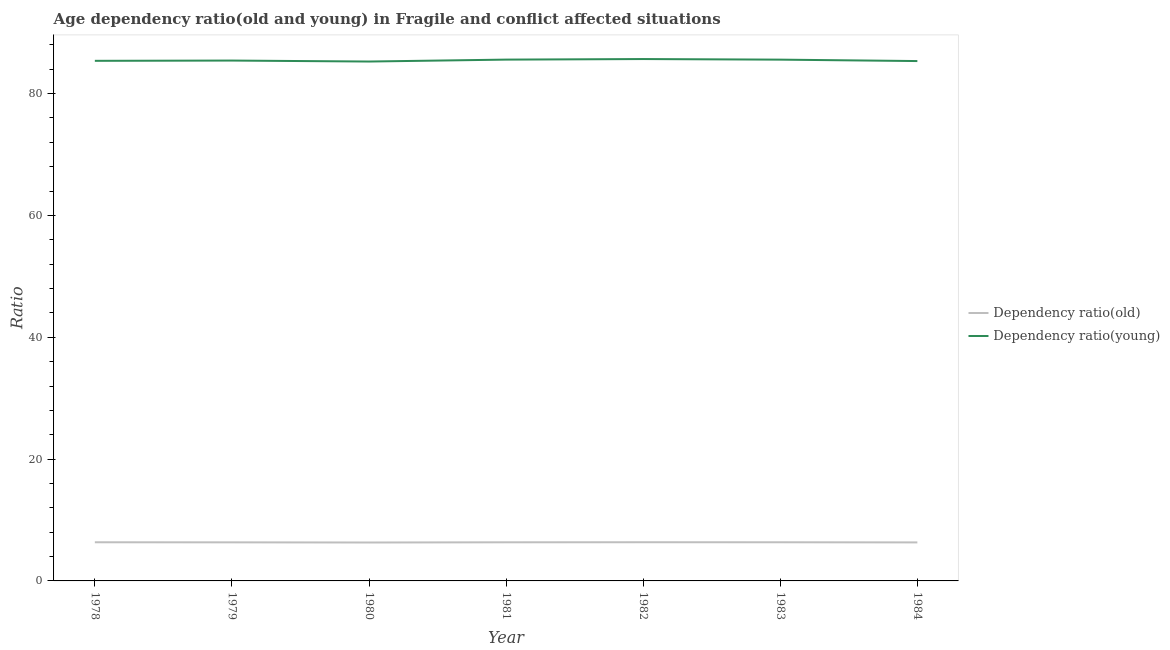Does the line corresponding to age dependency ratio(old) intersect with the line corresponding to age dependency ratio(young)?
Give a very brief answer. No. Is the number of lines equal to the number of legend labels?
Your answer should be compact. Yes. What is the age dependency ratio(young) in 1979?
Provide a succinct answer. 85.43. Across all years, what is the maximum age dependency ratio(old)?
Keep it short and to the point. 6.35. Across all years, what is the minimum age dependency ratio(young)?
Your answer should be compact. 85.27. In which year was the age dependency ratio(old) maximum?
Your answer should be compact. 1982. In which year was the age dependency ratio(old) minimum?
Provide a succinct answer. 1980. What is the total age dependency ratio(old) in the graph?
Offer a terse response. 44.35. What is the difference between the age dependency ratio(young) in 1979 and that in 1983?
Offer a terse response. -0.15. What is the difference between the age dependency ratio(young) in 1979 and the age dependency ratio(old) in 1984?
Your answer should be compact. 79.1. What is the average age dependency ratio(old) per year?
Your answer should be compact. 6.34. In the year 1980, what is the difference between the age dependency ratio(young) and age dependency ratio(old)?
Ensure brevity in your answer.  78.96. In how many years, is the age dependency ratio(young) greater than 68?
Keep it short and to the point. 7. What is the ratio of the age dependency ratio(old) in 1982 to that in 1983?
Provide a succinct answer. 1. Is the age dependency ratio(young) in 1979 less than that in 1981?
Make the answer very short. Yes. Is the difference between the age dependency ratio(young) in 1982 and 1984 greater than the difference between the age dependency ratio(old) in 1982 and 1984?
Give a very brief answer. Yes. What is the difference between the highest and the second highest age dependency ratio(young)?
Ensure brevity in your answer.  0.09. What is the difference between the highest and the lowest age dependency ratio(young)?
Ensure brevity in your answer.  0.41. In how many years, is the age dependency ratio(old) greater than the average age dependency ratio(old) taken over all years?
Your response must be concise. 4. How many years are there in the graph?
Keep it short and to the point. 7. What is the difference between two consecutive major ticks on the Y-axis?
Offer a very short reply. 20. Are the values on the major ticks of Y-axis written in scientific E-notation?
Provide a short and direct response. No. What is the title of the graph?
Your response must be concise. Age dependency ratio(old and young) in Fragile and conflict affected situations. What is the label or title of the X-axis?
Make the answer very short. Year. What is the label or title of the Y-axis?
Make the answer very short. Ratio. What is the Ratio of Dependency ratio(old) in 1978?
Give a very brief answer. 6.35. What is the Ratio of Dependency ratio(young) in 1978?
Your response must be concise. 85.39. What is the Ratio in Dependency ratio(old) in 1979?
Provide a succinct answer. 6.33. What is the Ratio in Dependency ratio(young) in 1979?
Ensure brevity in your answer.  85.43. What is the Ratio of Dependency ratio(old) in 1980?
Ensure brevity in your answer.  6.31. What is the Ratio in Dependency ratio(young) in 1980?
Your answer should be very brief. 85.27. What is the Ratio in Dependency ratio(old) in 1981?
Provide a short and direct response. 6.34. What is the Ratio of Dependency ratio(young) in 1981?
Your response must be concise. 85.58. What is the Ratio in Dependency ratio(old) in 1982?
Offer a terse response. 6.35. What is the Ratio in Dependency ratio(young) in 1982?
Your answer should be very brief. 85.68. What is the Ratio in Dependency ratio(old) in 1983?
Offer a terse response. 6.35. What is the Ratio in Dependency ratio(young) in 1983?
Your answer should be compact. 85.58. What is the Ratio of Dependency ratio(old) in 1984?
Your answer should be compact. 6.32. What is the Ratio of Dependency ratio(young) in 1984?
Provide a succinct answer. 85.35. Across all years, what is the maximum Ratio of Dependency ratio(old)?
Your answer should be compact. 6.35. Across all years, what is the maximum Ratio of Dependency ratio(young)?
Offer a terse response. 85.68. Across all years, what is the minimum Ratio in Dependency ratio(old)?
Keep it short and to the point. 6.31. Across all years, what is the minimum Ratio of Dependency ratio(young)?
Your response must be concise. 85.27. What is the total Ratio in Dependency ratio(old) in the graph?
Make the answer very short. 44.35. What is the total Ratio in Dependency ratio(young) in the graph?
Keep it short and to the point. 598.27. What is the difference between the Ratio of Dependency ratio(old) in 1978 and that in 1979?
Provide a short and direct response. 0.01. What is the difference between the Ratio of Dependency ratio(young) in 1978 and that in 1979?
Provide a short and direct response. -0.04. What is the difference between the Ratio in Dependency ratio(old) in 1978 and that in 1980?
Provide a short and direct response. 0.04. What is the difference between the Ratio of Dependency ratio(young) in 1978 and that in 1980?
Your answer should be very brief. 0.12. What is the difference between the Ratio in Dependency ratio(old) in 1978 and that in 1981?
Your response must be concise. 0.01. What is the difference between the Ratio of Dependency ratio(young) in 1978 and that in 1981?
Offer a terse response. -0.2. What is the difference between the Ratio of Dependency ratio(old) in 1978 and that in 1982?
Your response must be concise. -0.01. What is the difference between the Ratio in Dependency ratio(young) in 1978 and that in 1982?
Give a very brief answer. -0.29. What is the difference between the Ratio of Dependency ratio(young) in 1978 and that in 1983?
Offer a terse response. -0.19. What is the difference between the Ratio of Dependency ratio(old) in 1978 and that in 1984?
Offer a terse response. 0.02. What is the difference between the Ratio in Dependency ratio(young) in 1978 and that in 1984?
Your answer should be very brief. 0.04. What is the difference between the Ratio of Dependency ratio(old) in 1979 and that in 1980?
Your answer should be compact. 0.03. What is the difference between the Ratio of Dependency ratio(young) in 1979 and that in 1980?
Ensure brevity in your answer.  0.16. What is the difference between the Ratio of Dependency ratio(old) in 1979 and that in 1981?
Offer a terse response. -0.01. What is the difference between the Ratio in Dependency ratio(young) in 1979 and that in 1981?
Offer a terse response. -0.16. What is the difference between the Ratio in Dependency ratio(old) in 1979 and that in 1982?
Give a very brief answer. -0.02. What is the difference between the Ratio in Dependency ratio(young) in 1979 and that in 1982?
Ensure brevity in your answer.  -0.25. What is the difference between the Ratio of Dependency ratio(old) in 1979 and that in 1983?
Your response must be concise. -0.01. What is the difference between the Ratio in Dependency ratio(young) in 1979 and that in 1983?
Offer a very short reply. -0.15. What is the difference between the Ratio in Dependency ratio(old) in 1979 and that in 1984?
Keep it short and to the point. 0.01. What is the difference between the Ratio of Dependency ratio(young) in 1979 and that in 1984?
Ensure brevity in your answer.  0.08. What is the difference between the Ratio in Dependency ratio(old) in 1980 and that in 1981?
Ensure brevity in your answer.  -0.03. What is the difference between the Ratio in Dependency ratio(young) in 1980 and that in 1981?
Ensure brevity in your answer.  -0.32. What is the difference between the Ratio of Dependency ratio(old) in 1980 and that in 1982?
Offer a very short reply. -0.04. What is the difference between the Ratio of Dependency ratio(young) in 1980 and that in 1982?
Your response must be concise. -0.41. What is the difference between the Ratio of Dependency ratio(old) in 1980 and that in 1983?
Keep it short and to the point. -0.04. What is the difference between the Ratio of Dependency ratio(young) in 1980 and that in 1983?
Your answer should be compact. -0.31. What is the difference between the Ratio in Dependency ratio(old) in 1980 and that in 1984?
Ensure brevity in your answer.  -0.02. What is the difference between the Ratio in Dependency ratio(young) in 1980 and that in 1984?
Provide a succinct answer. -0.08. What is the difference between the Ratio in Dependency ratio(old) in 1981 and that in 1982?
Provide a short and direct response. -0.01. What is the difference between the Ratio of Dependency ratio(young) in 1981 and that in 1982?
Provide a succinct answer. -0.09. What is the difference between the Ratio in Dependency ratio(old) in 1981 and that in 1983?
Keep it short and to the point. -0.01. What is the difference between the Ratio in Dependency ratio(young) in 1981 and that in 1983?
Ensure brevity in your answer.  0.01. What is the difference between the Ratio in Dependency ratio(old) in 1981 and that in 1984?
Offer a terse response. 0.02. What is the difference between the Ratio of Dependency ratio(young) in 1981 and that in 1984?
Offer a very short reply. 0.24. What is the difference between the Ratio of Dependency ratio(old) in 1982 and that in 1983?
Make the answer very short. 0.01. What is the difference between the Ratio of Dependency ratio(young) in 1982 and that in 1983?
Keep it short and to the point. 0.1. What is the difference between the Ratio of Dependency ratio(old) in 1982 and that in 1984?
Provide a succinct answer. 0.03. What is the difference between the Ratio in Dependency ratio(young) in 1982 and that in 1984?
Ensure brevity in your answer.  0.33. What is the difference between the Ratio of Dependency ratio(old) in 1983 and that in 1984?
Your response must be concise. 0.02. What is the difference between the Ratio of Dependency ratio(young) in 1983 and that in 1984?
Give a very brief answer. 0.23. What is the difference between the Ratio of Dependency ratio(old) in 1978 and the Ratio of Dependency ratio(young) in 1979?
Provide a succinct answer. -79.08. What is the difference between the Ratio in Dependency ratio(old) in 1978 and the Ratio in Dependency ratio(young) in 1980?
Give a very brief answer. -78.92. What is the difference between the Ratio in Dependency ratio(old) in 1978 and the Ratio in Dependency ratio(young) in 1981?
Provide a short and direct response. -79.24. What is the difference between the Ratio of Dependency ratio(old) in 1978 and the Ratio of Dependency ratio(young) in 1982?
Your answer should be very brief. -79.33. What is the difference between the Ratio of Dependency ratio(old) in 1978 and the Ratio of Dependency ratio(young) in 1983?
Your answer should be compact. -79.23. What is the difference between the Ratio of Dependency ratio(old) in 1978 and the Ratio of Dependency ratio(young) in 1984?
Your response must be concise. -79. What is the difference between the Ratio in Dependency ratio(old) in 1979 and the Ratio in Dependency ratio(young) in 1980?
Make the answer very short. -78.94. What is the difference between the Ratio of Dependency ratio(old) in 1979 and the Ratio of Dependency ratio(young) in 1981?
Offer a terse response. -79.25. What is the difference between the Ratio of Dependency ratio(old) in 1979 and the Ratio of Dependency ratio(young) in 1982?
Ensure brevity in your answer.  -79.34. What is the difference between the Ratio of Dependency ratio(old) in 1979 and the Ratio of Dependency ratio(young) in 1983?
Offer a very short reply. -79.25. What is the difference between the Ratio in Dependency ratio(old) in 1979 and the Ratio in Dependency ratio(young) in 1984?
Keep it short and to the point. -79.01. What is the difference between the Ratio in Dependency ratio(old) in 1980 and the Ratio in Dependency ratio(young) in 1981?
Provide a short and direct response. -79.28. What is the difference between the Ratio in Dependency ratio(old) in 1980 and the Ratio in Dependency ratio(young) in 1982?
Ensure brevity in your answer.  -79.37. What is the difference between the Ratio in Dependency ratio(old) in 1980 and the Ratio in Dependency ratio(young) in 1983?
Your response must be concise. -79.27. What is the difference between the Ratio of Dependency ratio(old) in 1980 and the Ratio of Dependency ratio(young) in 1984?
Provide a succinct answer. -79.04. What is the difference between the Ratio of Dependency ratio(old) in 1981 and the Ratio of Dependency ratio(young) in 1982?
Ensure brevity in your answer.  -79.34. What is the difference between the Ratio in Dependency ratio(old) in 1981 and the Ratio in Dependency ratio(young) in 1983?
Offer a very short reply. -79.24. What is the difference between the Ratio of Dependency ratio(old) in 1981 and the Ratio of Dependency ratio(young) in 1984?
Offer a very short reply. -79.01. What is the difference between the Ratio in Dependency ratio(old) in 1982 and the Ratio in Dependency ratio(young) in 1983?
Provide a succinct answer. -79.23. What is the difference between the Ratio in Dependency ratio(old) in 1982 and the Ratio in Dependency ratio(young) in 1984?
Provide a succinct answer. -78.99. What is the difference between the Ratio in Dependency ratio(old) in 1983 and the Ratio in Dependency ratio(young) in 1984?
Provide a short and direct response. -79. What is the average Ratio in Dependency ratio(old) per year?
Offer a very short reply. 6.34. What is the average Ratio of Dependency ratio(young) per year?
Offer a terse response. 85.47. In the year 1978, what is the difference between the Ratio in Dependency ratio(old) and Ratio in Dependency ratio(young)?
Your response must be concise. -79.04. In the year 1979, what is the difference between the Ratio in Dependency ratio(old) and Ratio in Dependency ratio(young)?
Make the answer very short. -79.09. In the year 1980, what is the difference between the Ratio in Dependency ratio(old) and Ratio in Dependency ratio(young)?
Your answer should be very brief. -78.96. In the year 1981, what is the difference between the Ratio of Dependency ratio(old) and Ratio of Dependency ratio(young)?
Provide a short and direct response. -79.24. In the year 1982, what is the difference between the Ratio of Dependency ratio(old) and Ratio of Dependency ratio(young)?
Provide a succinct answer. -79.32. In the year 1983, what is the difference between the Ratio of Dependency ratio(old) and Ratio of Dependency ratio(young)?
Your answer should be compact. -79.23. In the year 1984, what is the difference between the Ratio of Dependency ratio(old) and Ratio of Dependency ratio(young)?
Offer a very short reply. -79.02. What is the ratio of the Ratio of Dependency ratio(old) in 1978 to that in 1980?
Make the answer very short. 1.01. What is the ratio of the Ratio of Dependency ratio(old) in 1978 to that in 1981?
Your answer should be very brief. 1. What is the ratio of the Ratio in Dependency ratio(young) in 1978 to that in 1982?
Make the answer very short. 1. What is the ratio of the Ratio of Dependency ratio(young) in 1978 to that in 1984?
Provide a short and direct response. 1. What is the ratio of the Ratio of Dependency ratio(old) in 1979 to that in 1981?
Your answer should be compact. 1. What is the ratio of the Ratio in Dependency ratio(young) in 1979 to that in 1981?
Offer a terse response. 1. What is the ratio of the Ratio of Dependency ratio(old) in 1979 to that in 1982?
Keep it short and to the point. 1. What is the ratio of the Ratio of Dependency ratio(young) in 1979 to that in 1982?
Ensure brevity in your answer.  1. What is the ratio of the Ratio in Dependency ratio(old) in 1979 to that in 1983?
Your answer should be very brief. 1. What is the ratio of the Ratio of Dependency ratio(young) in 1979 to that in 1983?
Offer a terse response. 1. What is the ratio of the Ratio in Dependency ratio(old) in 1979 to that in 1984?
Offer a terse response. 1. What is the ratio of the Ratio of Dependency ratio(old) in 1980 to that in 1981?
Make the answer very short. 0.99. What is the ratio of the Ratio in Dependency ratio(old) in 1980 to that in 1982?
Your answer should be compact. 0.99. What is the ratio of the Ratio of Dependency ratio(young) in 1980 to that in 1983?
Your answer should be very brief. 1. What is the ratio of the Ratio in Dependency ratio(young) in 1980 to that in 1984?
Give a very brief answer. 1. What is the ratio of the Ratio of Dependency ratio(young) in 1981 to that in 1982?
Your answer should be compact. 1. What is the ratio of the Ratio of Dependency ratio(old) in 1981 to that in 1983?
Keep it short and to the point. 1. What is the ratio of the Ratio in Dependency ratio(young) in 1981 to that in 1983?
Provide a succinct answer. 1. What is the ratio of the Ratio in Dependency ratio(old) in 1981 to that in 1984?
Ensure brevity in your answer.  1. What is the ratio of the Ratio of Dependency ratio(young) in 1982 to that in 1983?
Your answer should be very brief. 1. What is the ratio of the Ratio in Dependency ratio(young) in 1982 to that in 1984?
Offer a terse response. 1. What is the ratio of the Ratio of Dependency ratio(old) in 1983 to that in 1984?
Keep it short and to the point. 1. What is the difference between the highest and the second highest Ratio of Dependency ratio(old)?
Offer a terse response. 0.01. What is the difference between the highest and the second highest Ratio in Dependency ratio(young)?
Provide a succinct answer. 0.09. What is the difference between the highest and the lowest Ratio of Dependency ratio(old)?
Your answer should be compact. 0.04. What is the difference between the highest and the lowest Ratio of Dependency ratio(young)?
Provide a succinct answer. 0.41. 